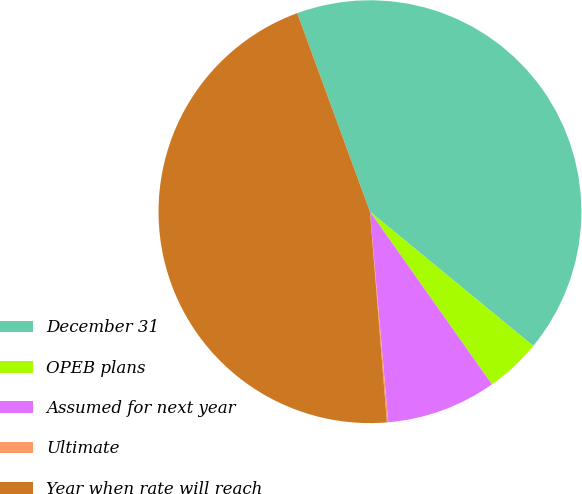Convert chart. <chart><loc_0><loc_0><loc_500><loc_500><pie_chart><fcel>December 31<fcel>OPEB plans<fcel>Assumed for next year<fcel>Ultimate<fcel>Year when rate will reach<nl><fcel>41.54%<fcel>4.26%<fcel>8.41%<fcel>0.1%<fcel>45.69%<nl></chart> 